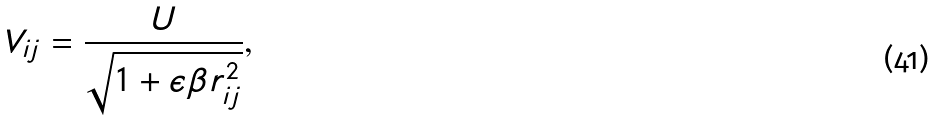Convert formula to latex. <formula><loc_0><loc_0><loc_500><loc_500>V _ { i j } = \frac { U } { \sqrt { 1 + \epsilon \beta r _ { i j } ^ { 2 } } } ,</formula> 